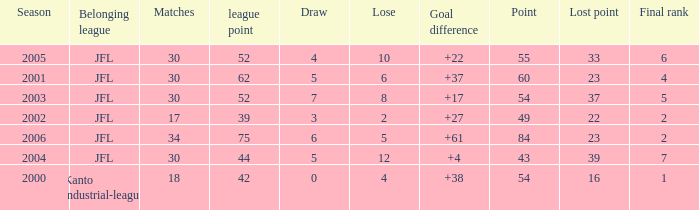I want the total number of matches for draw less than 7 and lost point of 16 with lose more than 4 0.0. 